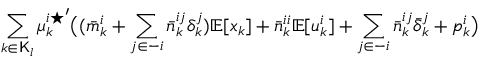Convert formula to latex. <formula><loc_0><loc_0><loc_500><loc_500>\sum _ { k \in K _ { l } } { \mu _ { k } ^ { i ^ { * } } } ^ { \prime } \left ( ( \bar { m } _ { k } ^ { i } + \sum _ { j \in - i } \bar { n } _ { k } ^ { i j } \delta _ { k } ^ { j } ) \mathbb { E } [ x _ { k } ] + \bar { n } _ { k } ^ { i i } \mathbb { E } [ u _ { k } ^ { i } ] + \sum _ { j \in - i } \bar { n } _ { k } ^ { i j } \bar { \delta } _ { k } ^ { j } + p _ { k } ^ { i } \right )</formula> 